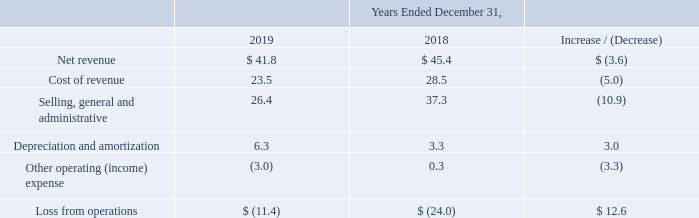Net revenue: Net revenue from our Broadcasting segment for the year ended December 31, 2019 decreased $3.6 million to $41.8 million from $45.4 million for the year ended December 31, 2018. During the second half of 2018, the Broadcasting segment undertook targeted cost cutting measures, primarily at HC2 Network Inc. ("Network") where Broadcasting exited certain local business operations and made strategic changes to the programming mix.
The decrease in net revenue was primarily due to lower local advertising sales as a result of such restructuring. This was partially offset by higher broadcast stations revenue associated with stations acquired during and subsequent to the comparable period.
Cost of revenue: Cost of revenue from our Broadcasting segment for the year ended December 31, 2019 decreased $5.0 million to $23.5 million from $28.5 million for the year ended December 31, 2018. The overall decrease was primarily driven by a reduction in audience measurement costs as a result of the exit of certain local markets which were unprofitable at Network and a decrease in programming costs due to changes in the programming mix referenced above, partially offset by higher cost of revenues associated with the growth of the Broadcast stations subsequent to the prior year.
Selling, general and administrative: Selling, general and administrative expenses from our Broadcasting segment for the year ended December 31, 2019 decreased $10.9 million to $26.4 million from $37.3 million for the year ended December 31, 2018. The decrease was primarily due to a reduction in compensation costs, mainly driven by the cost cutting measures discussed above and lower legal expenses related to elevated acquisition-related expenses incurred in the prior period.
Depreciation and amortization: Depreciation and amortization from our Broadcasting segment for the year ended December 31, 2019 increased $3.0 million to $6.3 million from $3.3 million for the year ended December 31, 2018. The increase was driven by additional amortization of fixed assets and definite lived intangible assets which were acquired as part of transactions subsequent to the comparable period.
Other operating (income) expense: Other operating (income) expense from our Broadcasting segment for the year ended December 31, 2019 increased $3.3 million to income of $3.0 million from expense of $0.3 million for the year ended December 31, 2018. The increase was driven by reimbursements from the Federal Communications Commission (the “FCC”), partially offset by the impairment of FCC licenses during 2019 resulting from strategic discussions to abandon certain licenses.
The FCC requires certain television stations to change channels and/or modify their transmission facilities. The U.S. Congress passed legislation which provides the FCC with a fund to reimburse all reasonable costs incurred by stations operating under full power and Class A licenses and a portion of the costs incurred by stations operating under a low power license that are reassigned to new channels.
What was the net revenue for the year ended December 31, 2019? $41.8 million. What was the selling, general and administrative expense for the year ended December 31, 2018? $26.4 million. What was the cost of revenue for the year ended December 31, 2019? $23.5 million. What was the percentage increase / (decrease) in the net revenue from 2018 to 2019?
Answer scale should be: percent. 41.8 / 45.4 - 1
Answer: -7.93. What was the average cost of revenue?
Answer scale should be: million. (23.5 + 28.5) / 2
Answer: 26. What is the percentage increase / (decrease) in the Depreciation and amortization from 2018 to 2019?
Answer scale should be: percent. 6.3 / 3.3 - 1
Answer: 90.91. 